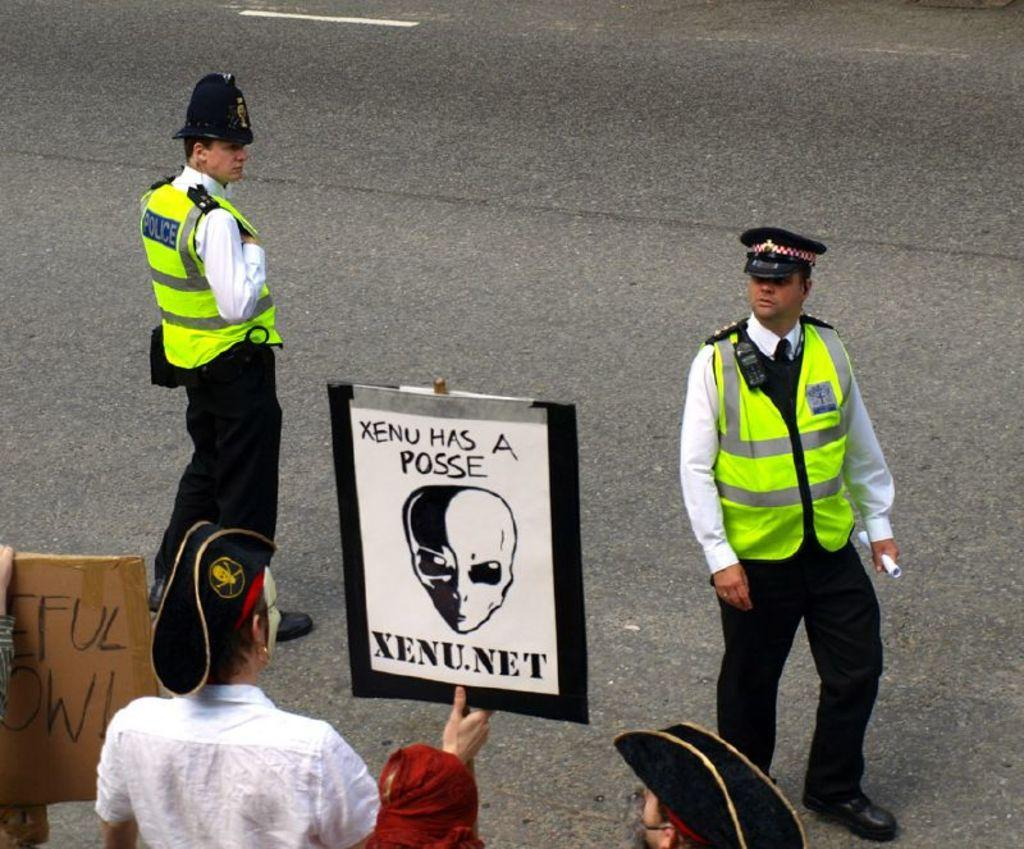Who or what can be seen in the image? There are people in the image. What are the people doing in the image? Some of the people are holding an object. Can you describe the object being held by the people? The object has written text on it. What else can be seen in the image besides the people and the object? There is a road visible in the image. What type of apparel is being mined in the image? There is no mention of apparel or mining in the image; it features people holding an object with written text on it and a road visible in the background. How many quivers can be seen in the image? There is no mention of quivers in the image; it features people holding an object with written text on it and a road visible in the background. 